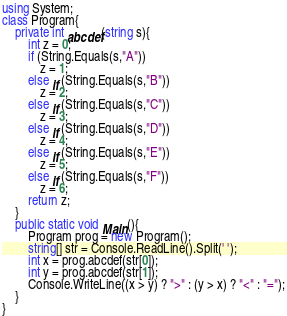Convert code to text. <code><loc_0><loc_0><loc_500><loc_500><_C#_>using System;
class Program{
	private int abcdef(string s){
		int z = 0;
		if (String.Equals(s,"A"))
			z = 1;
		else if (String.Equals(s,"B"))
			z = 2;
		else if (String.Equals(s,"C"))
			z = 3;
		else if (String.Equals(s,"D"))
			z = 4;
		else if (String.Equals(s,"E"))
			z = 5;
		else if (String.Equals(s,"F"))
			z = 6;
		return z;
	}
	public static void Main(){
		Program prog = new Program();
		string[] str = Console.ReadLine().Split(' ');
		int x = prog.abcdef(str[0]);
		int y = prog.abcdef(str[1]);
		Console.WriteLine((x > y) ? ">" : (y > x) ? "<" : "=");
	}
}</code> 